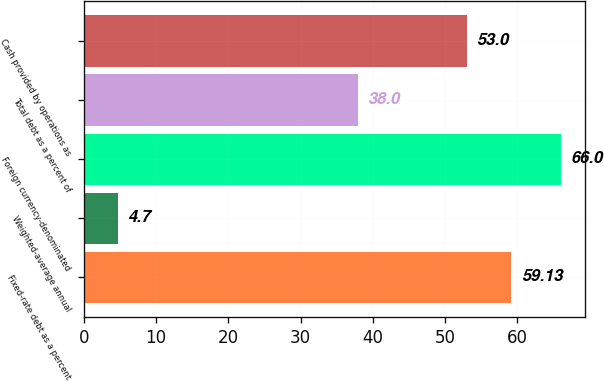Convert chart to OTSL. <chart><loc_0><loc_0><loc_500><loc_500><bar_chart><fcel>Fixed-rate debt as a percent<fcel>Weighted-average annual<fcel>Foreign currency-denominated<fcel>Total debt as a percent of<fcel>Cash provided by operations as<nl><fcel>59.13<fcel>4.7<fcel>66<fcel>38<fcel>53<nl></chart> 